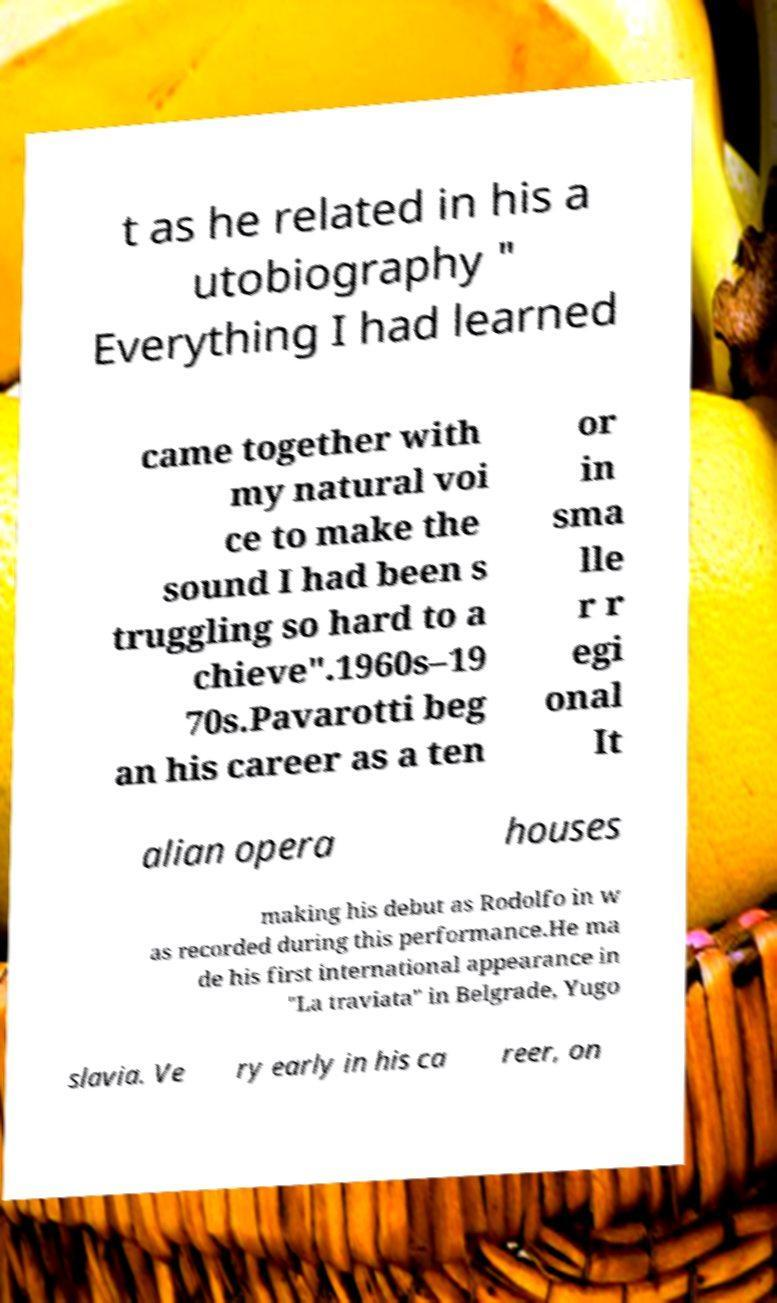For documentation purposes, I need the text within this image transcribed. Could you provide that? t as he related in his a utobiography " Everything I had learned came together with my natural voi ce to make the sound I had been s truggling so hard to a chieve".1960s–19 70s.Pavarotti beg an his career as a ten or in sma lle r r egi onal It alian opera houses making his debut as Rodolfo in w as recorded during this performance.He ma de his first international appearance in "La traviata" in Belgrade, Yugo slavia. Ve ry early in his ca reer, on 